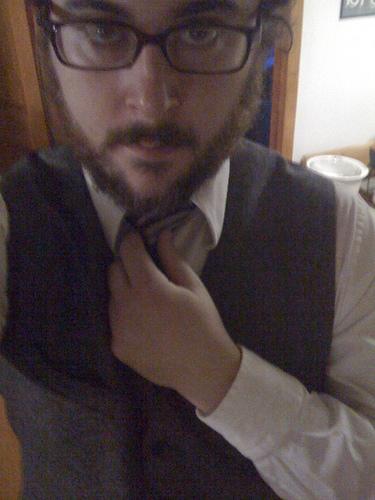Is he happy?
Short answer required. No. Where is the man?
Be succinct. Home. Is the man looking out the window?
Quick response, please. No. What the man holding?
Quick response, please. Tie. What color is the man's tie?
Give a very brief answer. Blue. What is the man doing in this photo?
Answer briefly. Fixing tie. What is the man's hand doing?
Give a very brief answer. Adjusting tie. IS this a fastidious man?
Short answer required. Yes. Is he looking away?
Short answer required. No. 